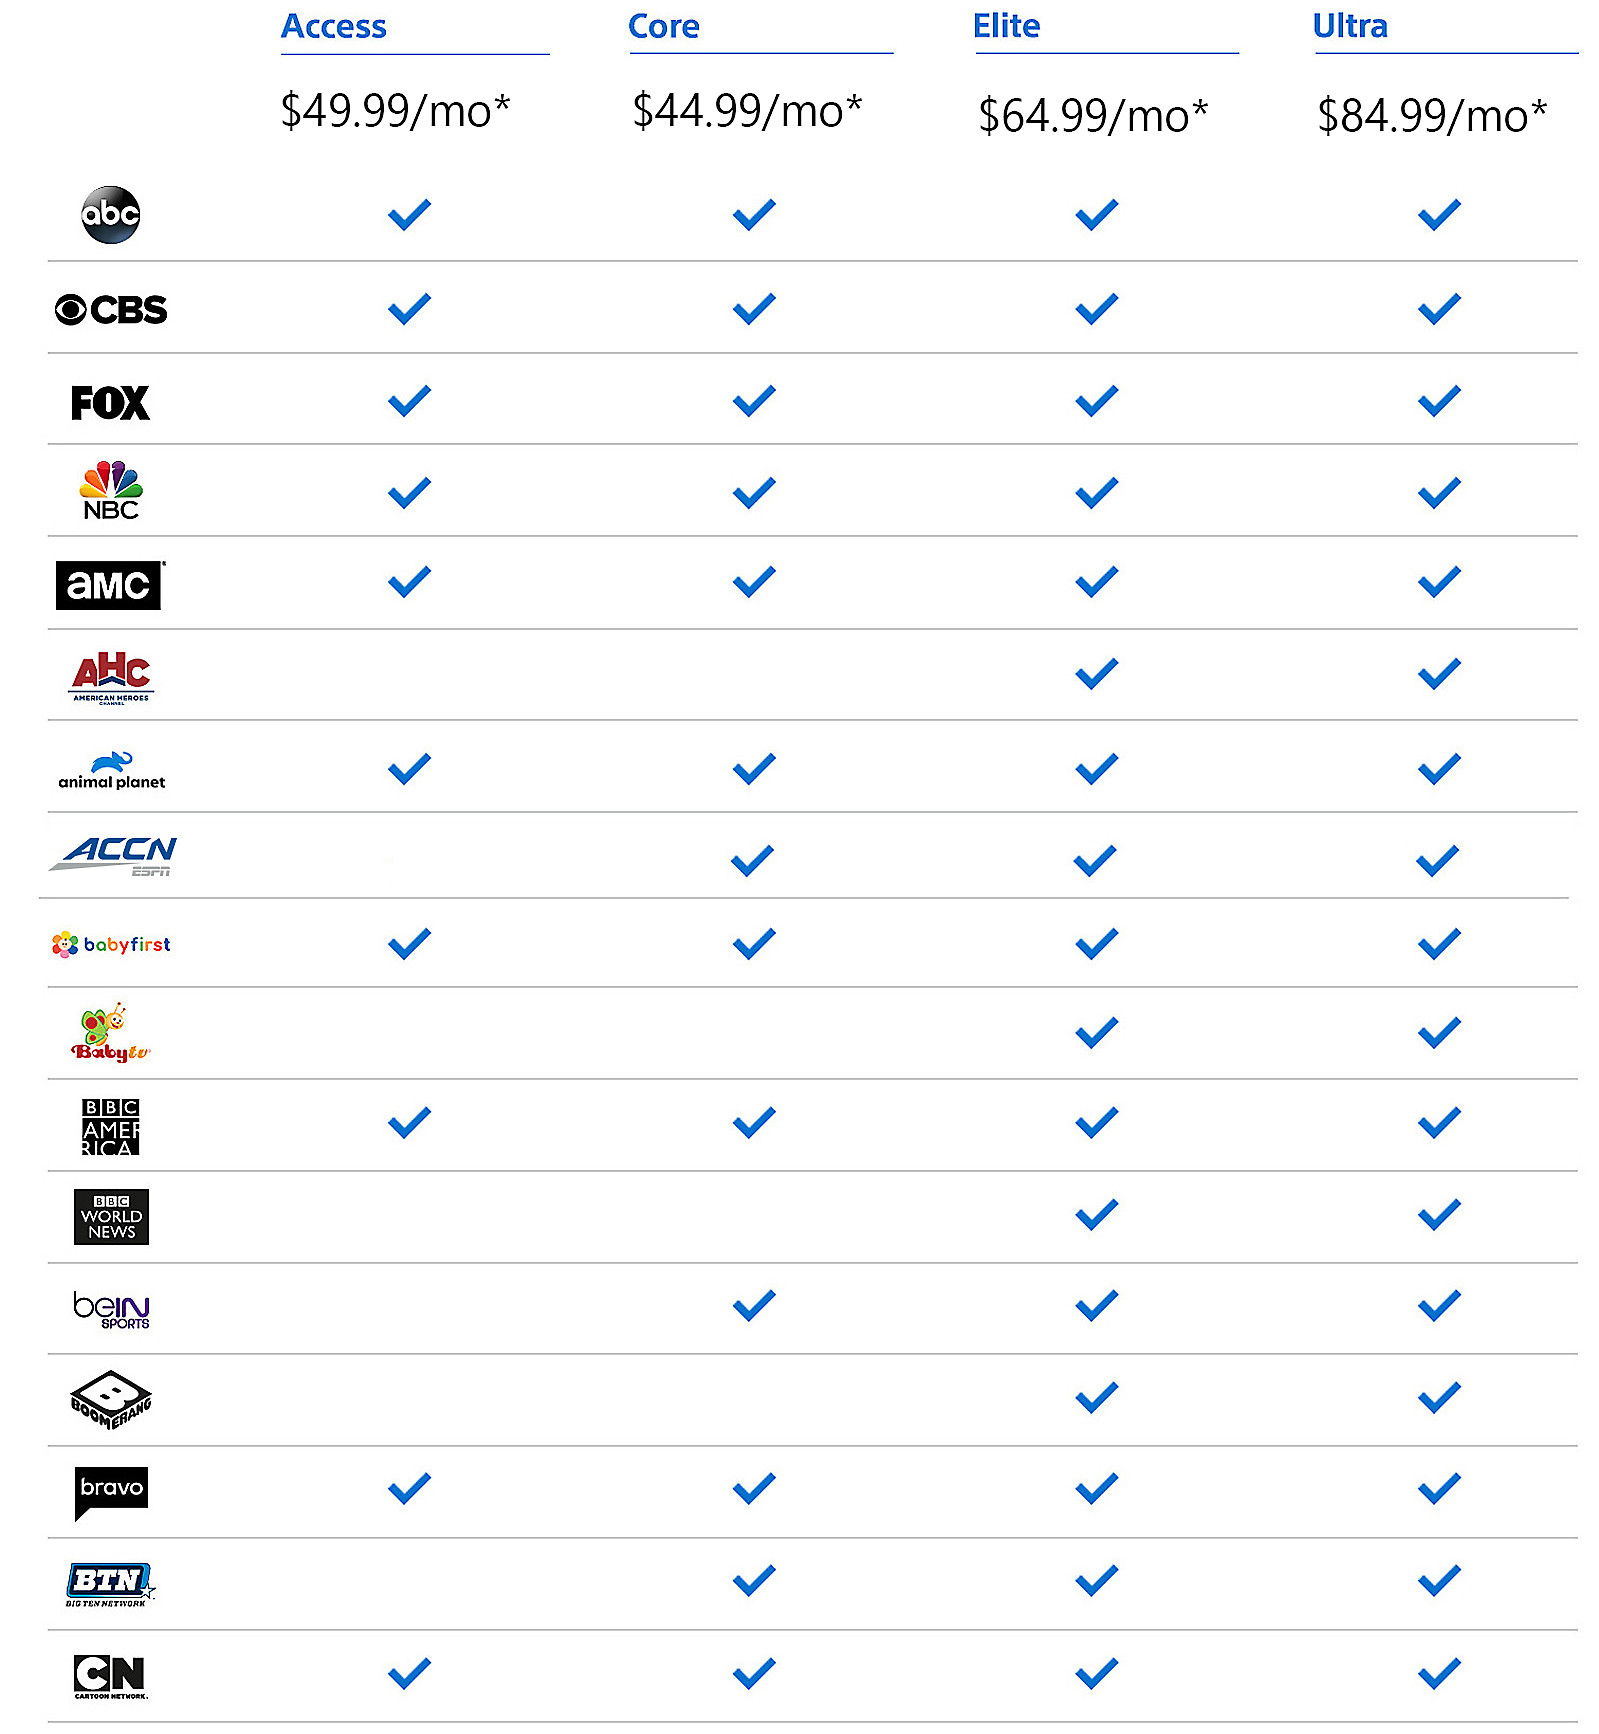Which channels are present in the Core package but not in the Access package? The channels that are included in the Core package but not in the Access package are BBC America and beIN SPORTS. This selection provides a broader range of entertainment and sports programming for those who opt for the Core package, offering an enriched viewing experience. 